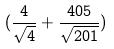<formula> <loc_0><loc_0><loc_500><loc_500>( \frac { 4 } { \sqrt { 4 } } + \frac { 4 0 5 } { \sqrt { 2 0 1 } } )</formula> 